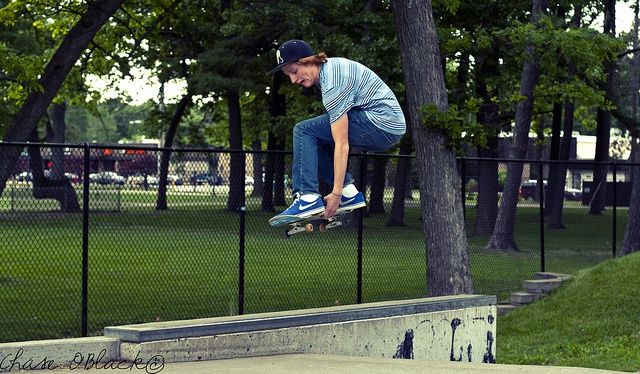Describe the objects in this image and their specific colors. I can see people in black, navy, white, and blue tones, skateboard in black, gray, darkgray, and blue tones, car in black, gray, and ivory tones, car in black, gray, navy, and darkgray tones, and car in black, gray, beige, darkgray, and khaki tones in this image. 